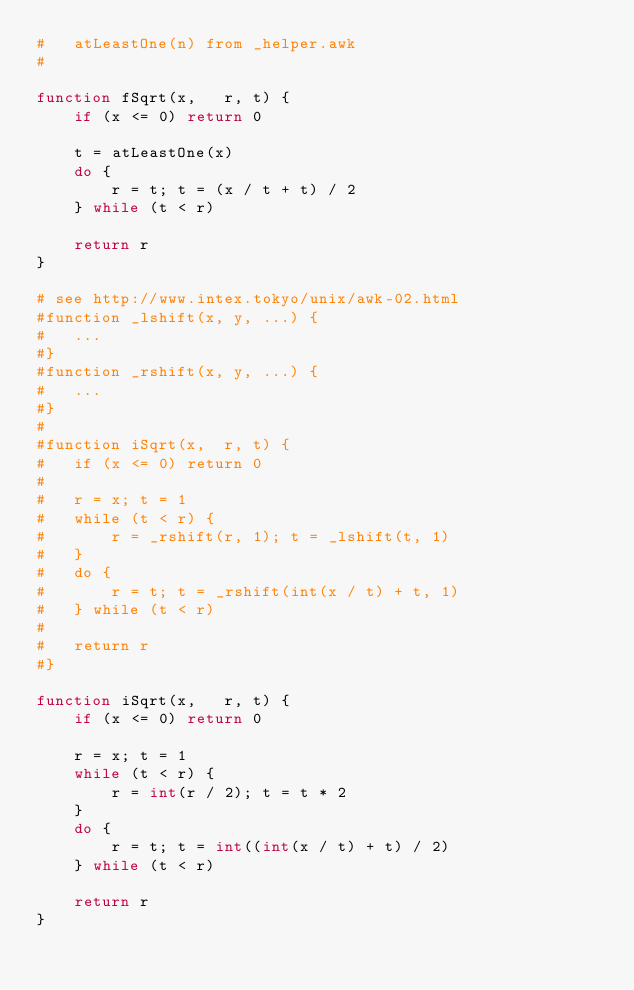<code> <loc_0><loc_0><loc_500><loc_500><_Awk_>#	atLeastOne(n) from _helper.awk
#

function fSqrt(x,	r, t) {
	if (x <= 0) return 0

	t = atLeastOne(x)
	do {
		r = t; t = (x / t + t) / 2
	} while (t < r)

	return r
}

# see http://www.intex.tokyo/unix/awk-02.html
#function _lshift(x, y,	...) {
#	...
#}
#function _rshift(x, y,	...) {
#	...
#}
#
#function iSqrt(x,	r, t) {
#	if (x <= 0) return 0
#
#	r = x; t = 1
#	while (t < r) {
#		r = _rshift(r, 1); t = _lshift(t, 1)
#	}
#	do {
#		r = t; t = _rshift(int(x / t) + t, 1)
#	} while (t < r)
#
#	return r
#}

function iSqrt(x,	r, t) {
	if (x <= 0) return 0

	r = x; t = 1
	while (t < r) {
		r = int(r / 2); t = t * 2
	}
	do {
		r = t; t = int((int(x / t) + t) / 2)
	} while (t < r)

	return r
}
</code> 